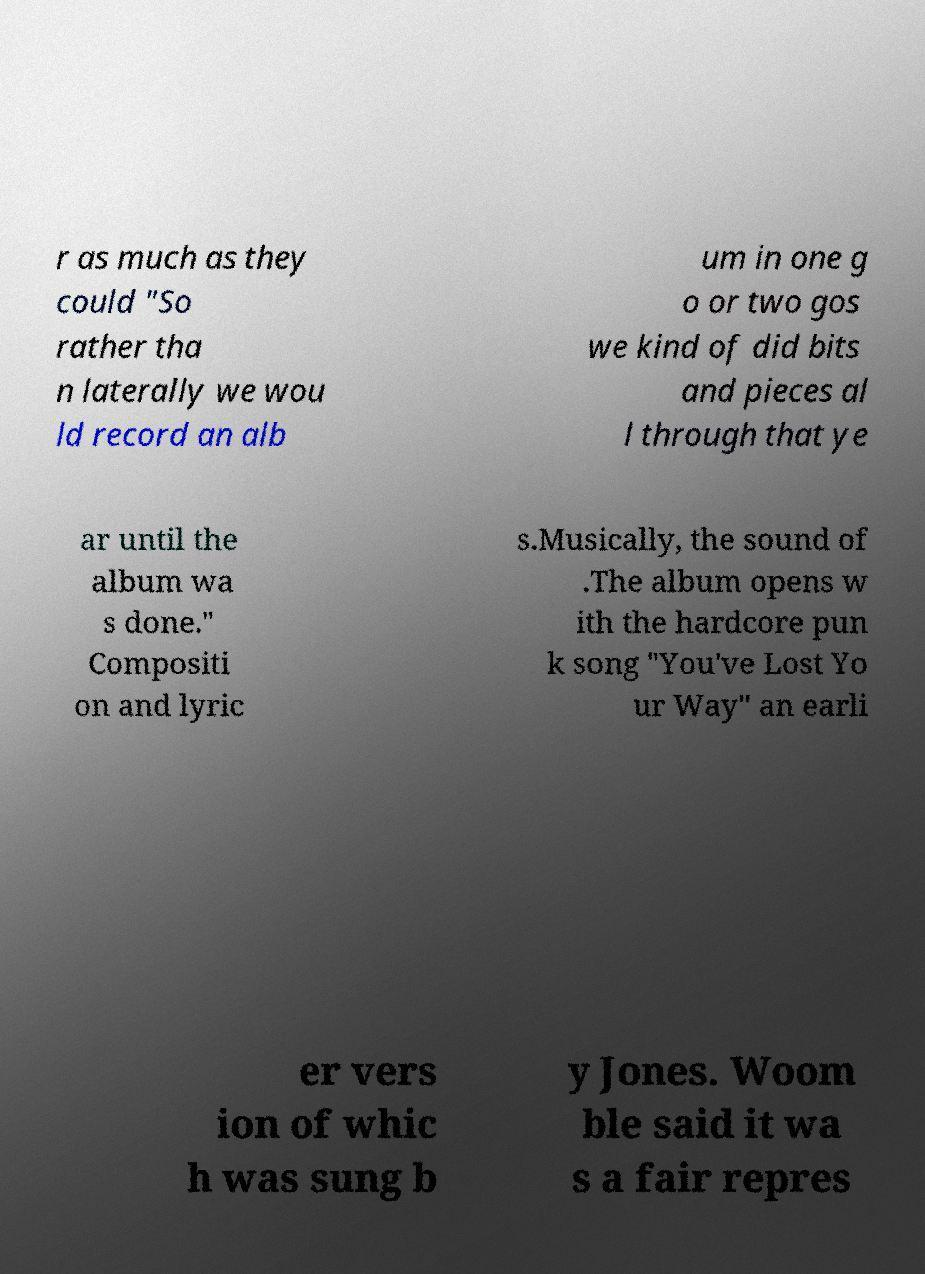Can you read and provide the text displayed in the image?This photo seems to have some interesting text. Can you extract and type it out for me? r as much as they could "So rather tha n laterally we wou ld record an alb um in one g o or two gos we kind of did bits and pieces al l through that ye ar until the album wa s done." Compositi on and lyric s.Musically, the sound of .The album opens w ith the hardcore pun k song "You've Lost Yo ur Way" an earli er vers ion of whic h was sung b y Jones. Woom ble said it wa s a fair repres 